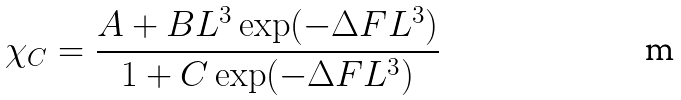<formula> <loc_0><loc_0><loc_500><loc_500>\chi _ { C } = \frac { A + B L ^ { 3 } \exp ( - \Delta F L ^ { 3 } ) } { 1 + C \exp ( - \Delta F L ^ { 3 } ) }</formula> 